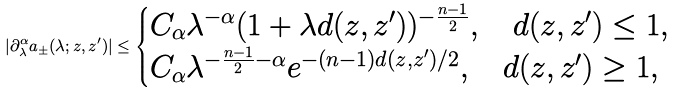<formula> <loc_0><loc_0><loc_500><loc_500>| \partial _ { \lambda } ^ { \alpha } a _ { \pm } ( \lambda ; z , z ^ { \prime } ) | \leq \begin{cases} C _ { \alpha } \lambda ^ { - \alpha } ( 1 + \lambda d ( z , z ^ { \prime } ) ) ^ { - \frac { n - 1 } 2 } , \quad d ( z , z ^ { \prime } ) \leq 1 , \\ C _ { \alpha } \lambda ^ { - \frac { n - 1 } 2 - \alpha } e ^ { - ( n - 1 ) d ( z , z ^ { \prime } ) / 2 } , \quad d ( z , z ^ { \prime } ) \geq 1 , \end{cases}</formula> 